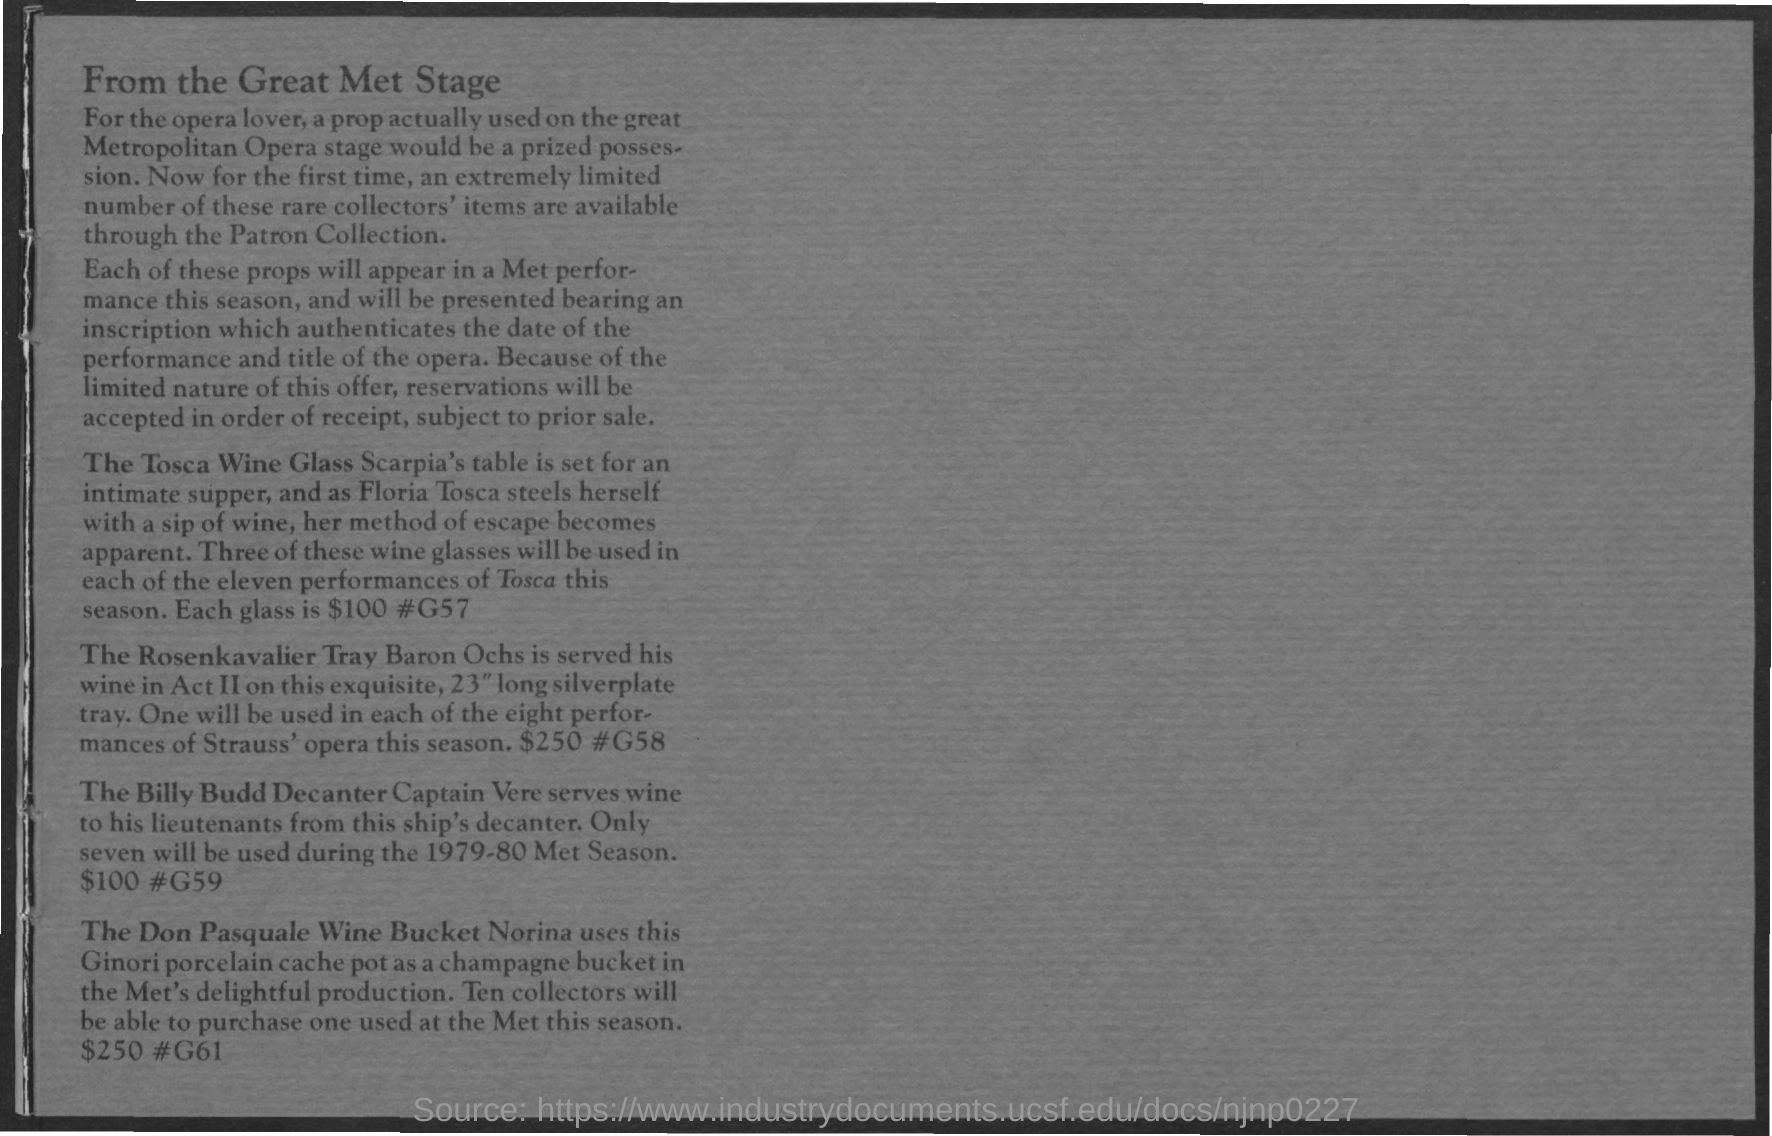Outline some significant characteristics in this image. The first title in the document is 'From the Great Metropolitan Stage of the World: A Tribute to the Late, Great Dionne Warwick.' 